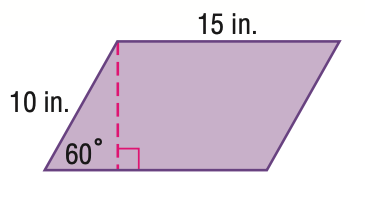Answer the mathemtical geometry problem and directly provide the correct option letter.
Question: Find the area of the figure. Round to the nearest tenth.
Choices: A: 75 B: 106.1 C: 129.9 D: 259.8 C 